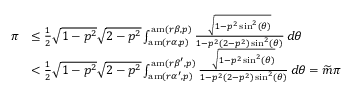Convert formula to latex. <formula><loc_0><loc_0><loc_500><loc_500>\begin{array} { r l } { \pi } & { \leq \frac { 1 } { 2 } \sqrt { 1 - p ^ { 2 } } \sqrt { 2 - p ^ { 2 } } \int _ { a m ( r \alpha , p ) } ^ { a m ( r \beta , p ) } \frac { \sqrt { 1 - p ^ { 2 } \sin ^ { 2 } ( \theta ) } } { 1 - p ^ { 2 } ( 2 - p ^ { 2 } ) \sin ^ { 2 } ( \theta ) } \, d \theta } \\ & { < \frac { 1 } { 2 } \sqrt { 1 - p ^ { 2 } } \sqrt { 2 - p ^ { 2 } } \int _ { a m ( r \alpha ^ { \prime } , p ) } ^ { a m ( r \beta ^ { \prime } , p ) } \frac { \sqrt { 1 - p ^ { 2 } \sin ^ { 2 } ( \theta ) } } { 1 - p ^ { 2 } ( 2 - p ^ { 2 } ) \sin ^ { 2 } ( \theta ) } \, d \theta = \widetilde { m } \pi } \end{array}</formula> 